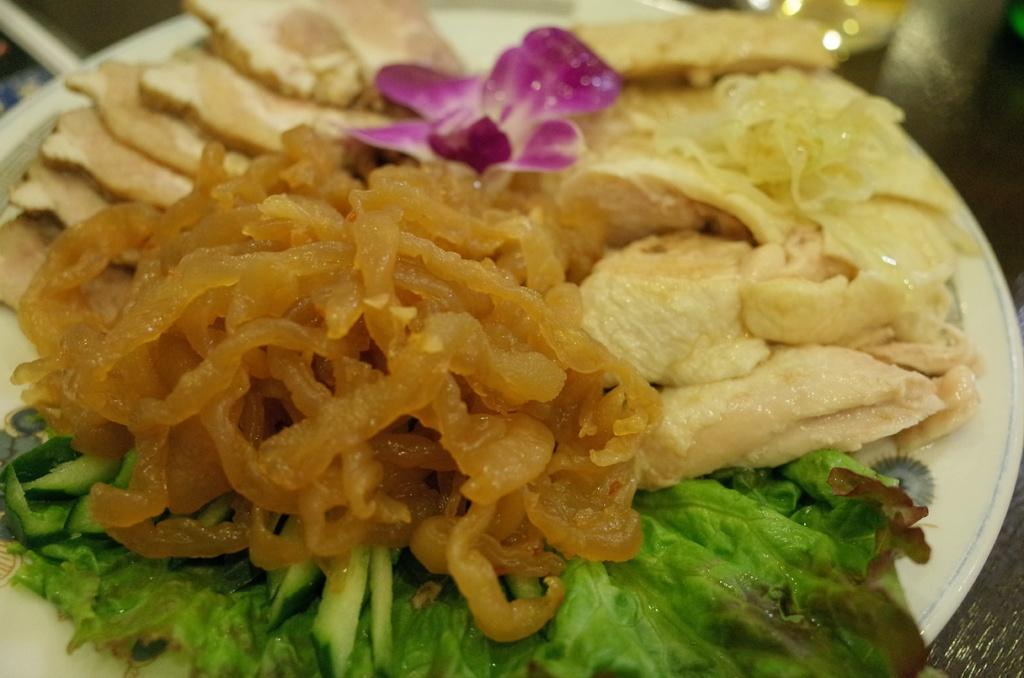What is on the plate in the image? There is a plate of food items in the image. What additional object can be seen in the image? A flower is visible in the image. Where is the crown placed in the image? There is no crown present in the image. How many birds are in the flock in the image? There is no flock of birds present in the image. 